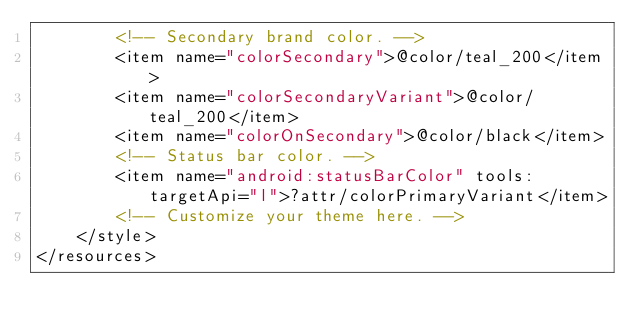<code> <loc_0><loc_0><loc_500><loc_500><_XML_>        <!-- Secondary brand color. -->
        <item name="colorSecondary">@color/teal_200</item>
        <item name="colorSecondaryVariant">@color/teal_200</item>
        <item name="colorOnSecondary">@color/black</item>
        <!-- Status bar color. -->
        <item name="android:statusBarColor" tools:targetApi="l">?attr/colorPrimaryVariant</item>
        <!-- Customize your theme here. -->
    </style>
</resources></code> 